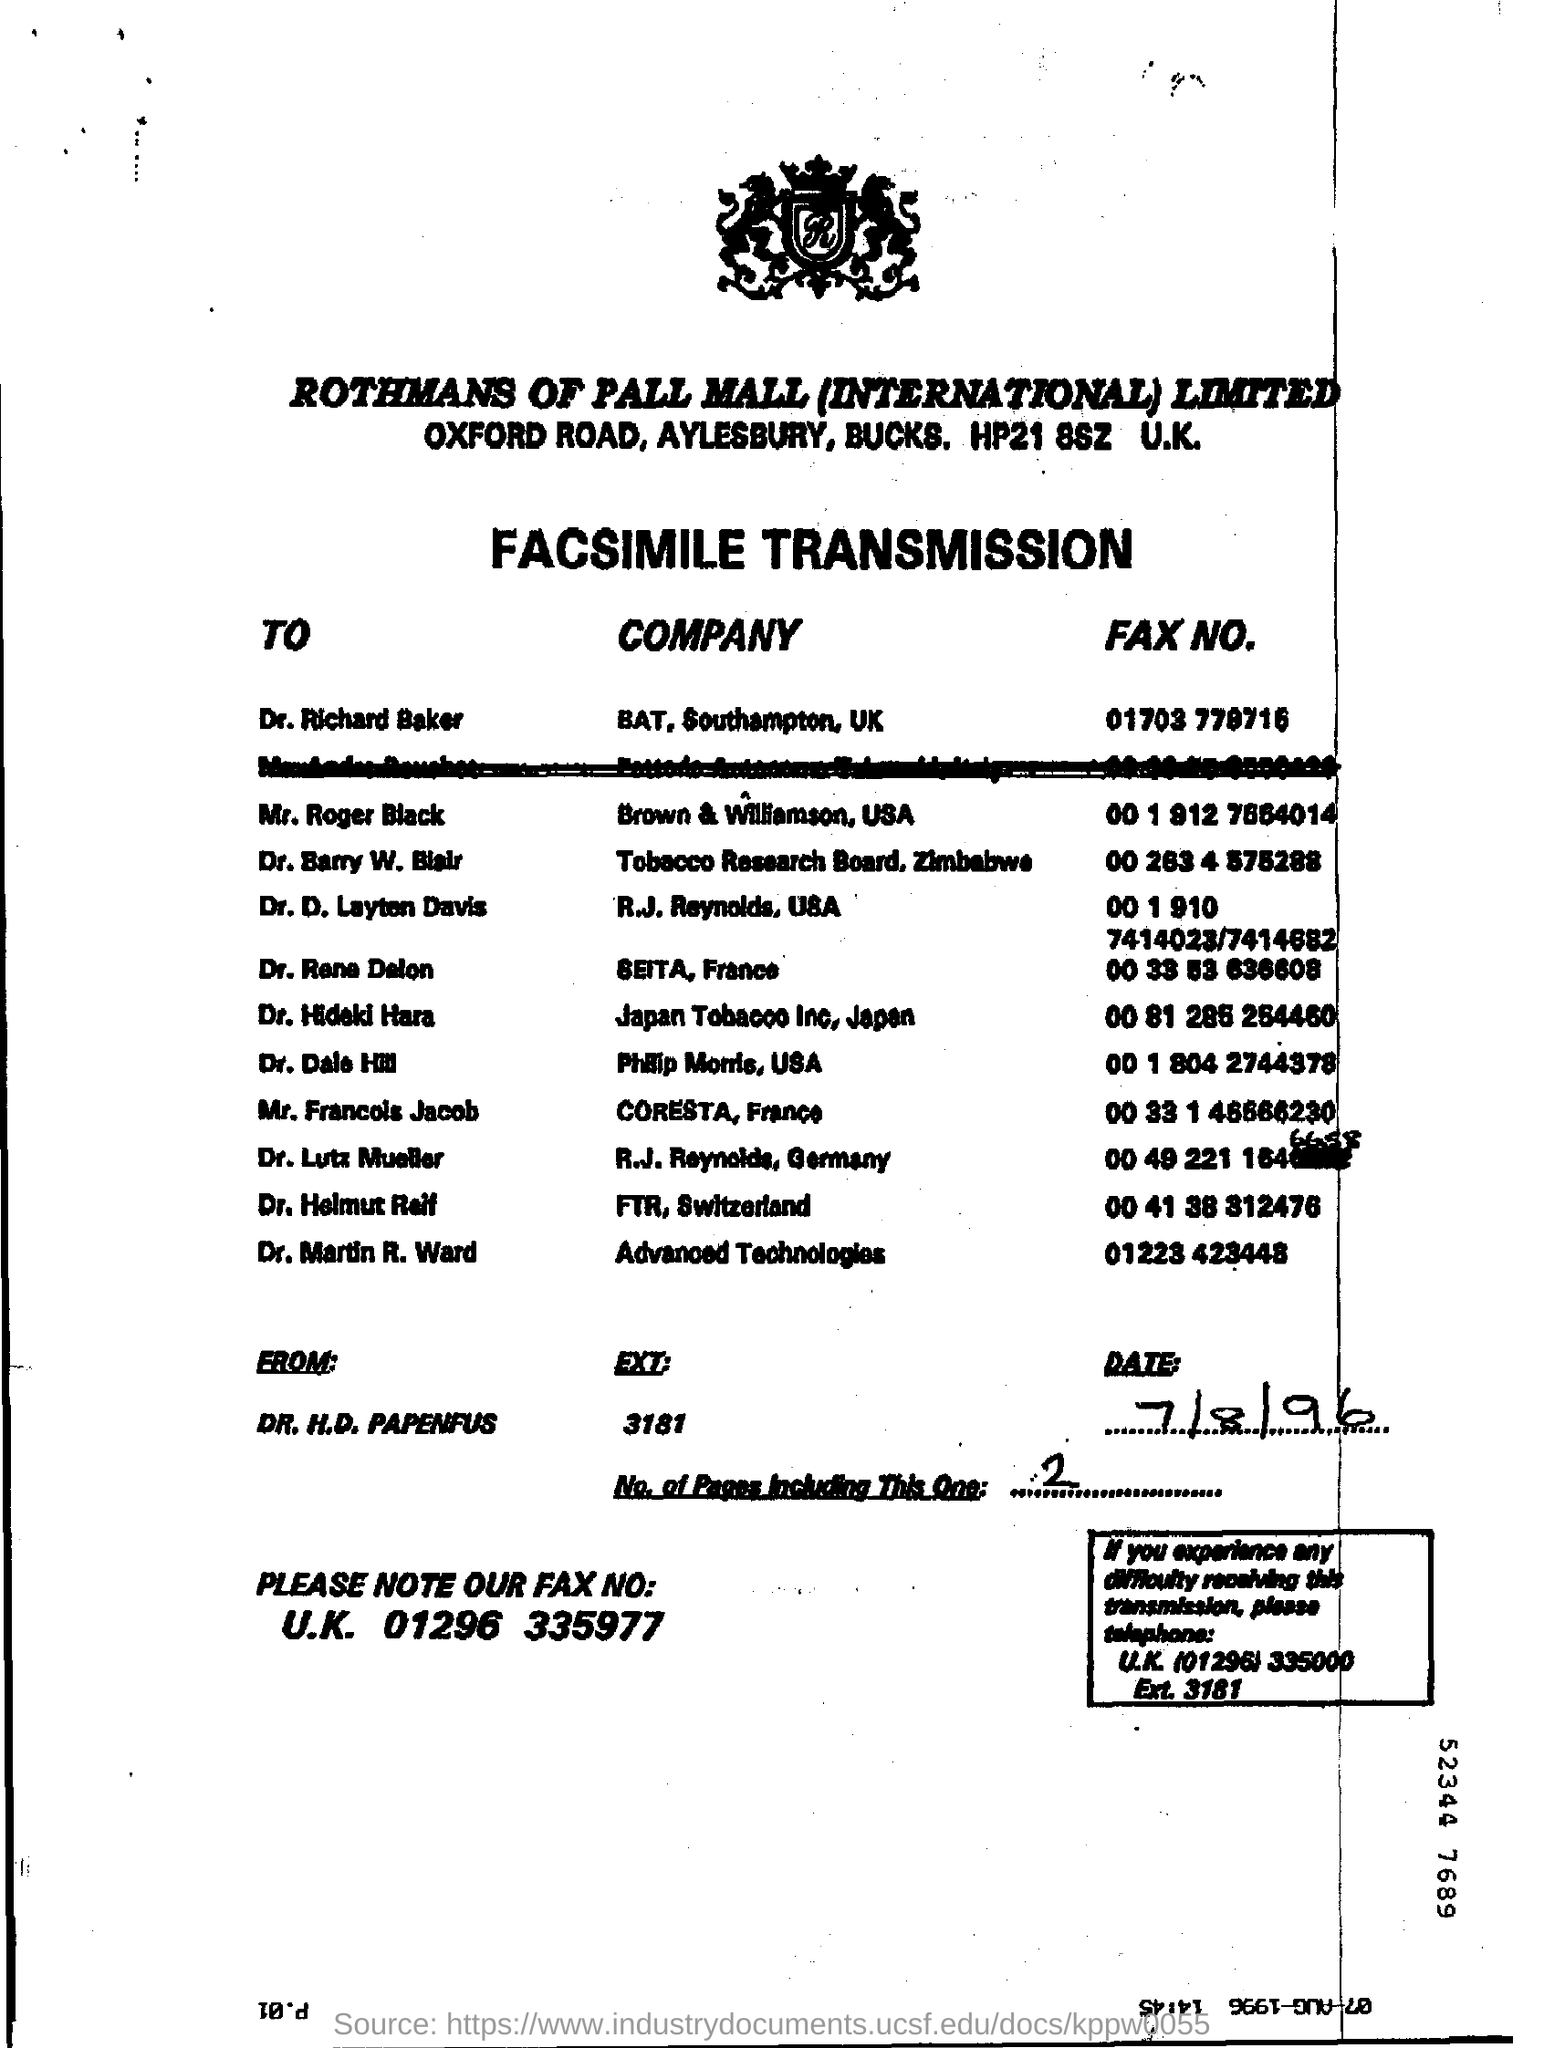Which company's fax transmission is this?
Provide a succinct answer. ROTHMANS OF PALL MALL (INTERNATIONAL) LIMITED. Who is the sender of the FAX?
Your answer should be compact. DR. H.D. PAPENFUS. What is the EXT mentioned in the fax?
Your answer should be very brief. 3181. What is the date mentioned here?
Offer a terse response. 7/8/96. In which company, Dr. Martin R. Ward  works?
Your response must be concise. Advanced Technologies. 